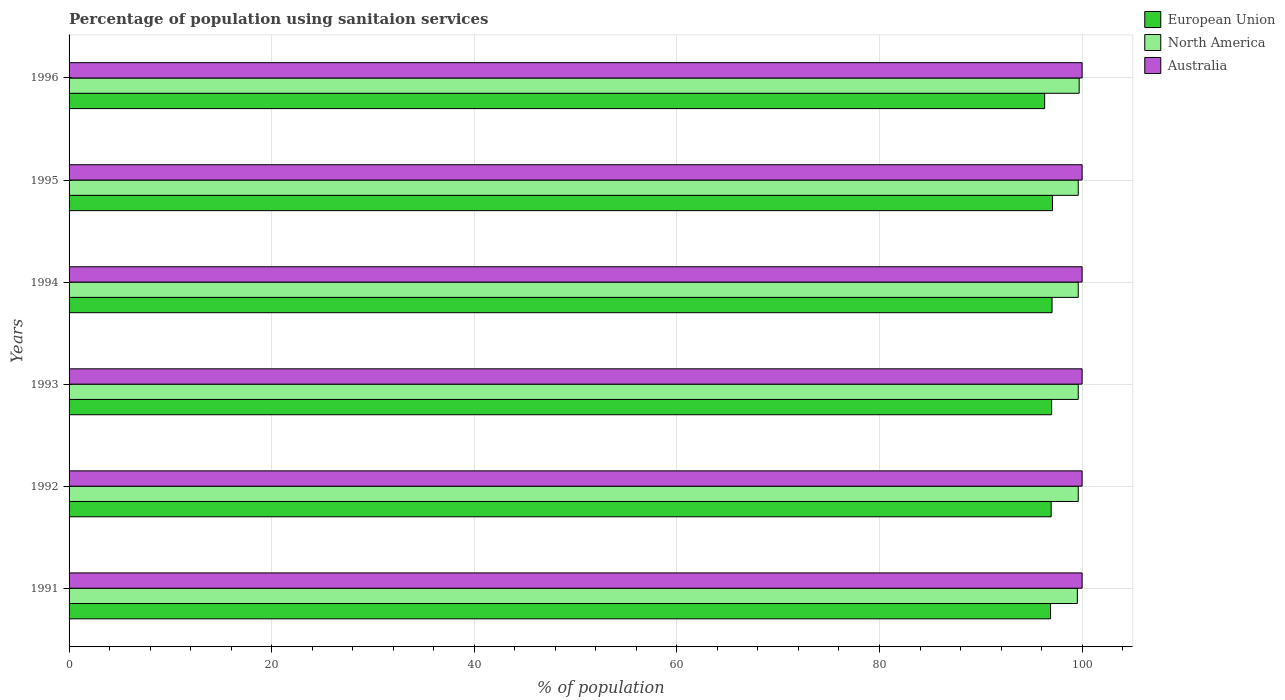How many different coloured bars are there?
Keep it short and to the point. 3. Are the number of bars per tick equal to the number of legend labels?
Give a very brief answer. Yes. How many bars are there on the 4th tick from the bottom?
Ensure brevity in your answer.  3. In how many cases, is the number of bars for a given year not equal to the number of legend labels?
Ensure brevity in your answer.  0. What is the percentage of population using sanitaion services in Australia in 1996?
Offer a terse response. 100. Across all years, what is the maximum percentage of population using sanitaion services in North America?
Provide a short and direct response. 99.71. Across all years, what is the minimum percentage of population using sanitaion services in North America?
Your answer should be compact. 99.53. What is the total percentage of population using sanitaion services in Australia in the graph?
Keep it short and to the point. 600. What is the difference between the percentage of population using sanitaion services in European Union in 1991 and that in 1993?
Ensure brevity in your answer.  -0.11. What is the difference between the percentage of population using sanitaion services in Australia in 1994 and the percentage of population using sanitaion services in European Union in 1996?
Give a very brief answer. 3.7. In the year 1995, what is the difference between the percentage of population using sanitaion services in European Union and percentage of population using sanitaion services in Australia?
Keep it short and to the point. -2.92. In how many years, is the percentage of population using sanitaion services in North America greater than 32 %?
Ensure brevity in your answer.  6. What is the ratio of the percentage of population using sanitaion services in Australia in 1993 to that in 1996?
Ensure brevity in your answer.  1. Is the percentage of population using sanitaion services in Australia in 1993 less than that in 1994?
Your answer should be very brief. No. Is the difference between the percentage of population using sanitaion services in European Union in 1991 and 1995 greater than the difference between the percentage of population using sanitaion services in Australia in 1991 and 1995?
Make the answer very short. No. What is the difference between the highest and the lowest percentage of population using sanitaion services in European Union?
Make the answer very short. 0.77. Is the sum of the percentage of population using sanitaion services in European Union in 1991 and 1993 greater than the maximum percentage of population using sanitaion services in North America across all years?
Keep it short and to the point. Yes. How many bars are there?
Keep it short and to the point. 18. How many years are there in the graph?
Ensure brevity in your answer.  6. Are the values on the major ticks of X-axis written in scientific E-notation?
Provide a short and direct response. No. Does the graph contain any zero values?
Keep it short and to the point. No. Does the graph contain grids?
Provide a succinct answer. Yes. Where does the legend appear in the graph?
Ensure brevity in your answer.  Top right. What is the title of the graph?
Keep it short and to the point. Percentage of population using sanitaion services. What is the label or title of the X-axis?
Provide a short and direct response. % of population. What is the label or title of the Y-axis?
Provide a succinct answer. Years. What is the % of population of European Union in 1991?
Offer a very short reply. 96.89. What is the % of population of North America in 1991?
Your answer should be very brief. 99.53. What is the % of population of Australia in 1991?
Your response must be concise. 100. What is the % of population in European Union in 1992?
Provide a succinct answer. 96.95. What is the % of population of North America in 1992?
Make the answer very short. 99.62. What is the % of population of Australia in 1992?
Provide a succinct answer. 100. What is the % of population in European Union in 1993?
Your response must be concise. 96.99. What is the % of population in North America in 1993?
Provide a succinct answer. 99.62. What is the % of population of European Union in 1994?
Keep it short and to the point. 97.03. What is the % of population in North America in 1994?
Keep it short and to the point. 99.62. What is the % of population in European Union in 1995?
Give a very brief answer. 97.08. What is the % of population of North America in 1995?
Give a very brief answer. 99.62. What is the % of population in Australia in 1995?
Provide a succinct answer. 100. What is the % of population in European Union in 1996?
Ensure brevity in your answer.  96.3. What is the % of population in North America in 1996?
Ensure brevity in your answer.  99.71. What is the % of population in Australia in 1996?
Provide a short and direct response. 100. Across all years, what is the maximum % of population of European Union?
Provide a succinct answer. 97.08. Across all years, what is the maximum % of population of North America?
Ensure brevity in your answer.  99.71. Across all years, what is the maximum % of population of Australia?
Provide a short and direct response. 100. Across all years, what is the minimum % of population in European Union?
Provide a succinct answer. 96.3. Across all years, what is the minimum % of population of North America?
Make the answer very short. 99.53. What is the total % of population in European Union in the graph?
Make the answer very short. 581.24. What is the total % of population in North America in the graph?
Provide a short and direct response. 597.72. What is the total % of population in Australia in the graph?
Keep it short and to the point. 600. What is the difference between the % of population in European Union in 1991 and that in 1992?
Provide a short and direct response. -0.06. What is the difference between the % of population of North America in 1991 and that in 1992?
Your response must be concise. -0.09. What is the difference between the % of population of Australia in 1991 and that in 1992?
Your response must be concise. 0. What is the difference between the % of population in European Union in 1991 and that in 1993?
Offer a terse response. -0.11. What is the difference between the % of population of North America in 1991 and that in 1993?
Provide a short and direct response. -0.09. What is the difference between the % of population of Australia in 1991 and that in 1993?
Provide a succinct answer. 0. What is the difference between the % of population in European Union in 1991 and that in 1994?
Provide a short and direct response. -0.15. What is the difference between the % of population in North America in 1991 and that in 1994?
Your answer should be compact. -0.09. What is the difference between the % of population of Australia in 1991 and that in 1994?
Your answer should be very brief. 0. What is the difference between the % of population in European Union in 1991 and that in 1995?
Offer a very short reply. -0.19. What is the difference between the % of population of North America in 1991 and that in 1995?
Offer a very short reply. -0.09. What is the difference between the % of population in European Union in 1991 and that in 1996?
Your response must be concise. 0.58. What is the difference between the % of population in North America in 1991 and that in 1996?
Offer a very short reply. -0.18. What is the difference between the % of population of European Union in 1992 and that in 1993?
Make the answer very short. -0.05. What is the difference between the % of population of North America in 1992 and that in 1993?
Give a very brief answer. 0. What is the difference between the % of population of European Union in 1992 and that in 1994?
Provide a succinct answer. -0.09. What is the difference between the % of population in Australia in 1992 and that in 1994?
Ensure brevity in your answer.  0. What is the difference between the % of population in European Union in 1992 and that in 1995?
Your answer should be very brief. -0.13. What is the difference between the % of population of North America in 1992 and that in 1995?
Your response must be concise. 0. What is the difference between the % of population of European Union in 1992 and that in 1996?
Ensure brevity in your answer.  0.64. What is the difference between the % of population in North America in 1992 and that in 1996?
Your answer should be very brief. -0.09. What is the difference between the % of population in Australia in 1992 and that in 1996?
Provide a succinct answer. 0. What is the difference between the % of population in European Union in 1993 and that in 1994?
Offer a terse response. -0.04. What is the difference between the % of population in Australia in 1993 and that in 1994?
Offer a terse response. 0. What is the difference between the % of population in European Union in 1993 and that in 1995?
Provide a succinct answer. -0.08. What is the difference between the % of population of North America in 1993 and that in 1995?
Offer a terse response. 0. What is the difference between the % of population in Australia in 1993 and that in 1995?
Offer a very short reply. 0. What is the difference between the % of population of European Union in 1993 and that in 1996?
Your answer should be very brief. 0.69. What is the difference between the % of population of North America in 1993 and that in 1996?
Give a very brief answer. -0.09. What is the difference between the % of population in European Union in 1994 and that in 1995?
Provide a succinct answer. -0.04. What is the difference between the % of population in North America in 1994 and that in 1995?
Keep it short and to the point. 0. What is the difference between the % of population of Australia in 1994 and that in 1995?
Provide a succinct answer. 0. What is the difference between the % of population in European Union in 1994 and that in 1996?
Make the answer very short. 0.73. What is the difference between the % of population of North America in 1994 and that in 1996?
Offer a very short reply. -0.09. What is the difference between the % of population in European Union in 1995 and that in 1996?
Your response must be concise. 0.77. What is the difference between the % of population of North America in 1995 and that in 1996?
Offer a terse response. -0.09. What is the difference between the % of population of European Union in 1991 and the % of population of North America in 1992?
Provide a short and direct response. -2.73. What is the difference between the % of population of European Union in 1991 and the % of population of Australia in 1992?
Make the answer very short. -3.11. What is the difference between the % of population in North America in 1991 and the % of population in Australia in 1992?
Keep it short and to the point. -0.47. What is the difference between the % of population in European Union in 1991 and the % of population in North America in 1993?
Provide a short and direct response. -2.73. What is the difference between the % of population of European Union in 1991 and the % of population of Australia in 1993?
Give a very brief answer. -3.11. What is the difference between the % of population of North America in 1991 and the % of population of Australia in 1993?
Your answer should be compact. -0.47. What is the difference between the % of population of European Union in 1991 and the % of population of North America in 1994?
Provide a short and direct response. -2.73. What is the difference between the % of population of European Union in 1991 and the % of population of Australia in 1994?
Your answer should be compact. -3.11. What is the difference between the % of population in North America in 1991 and the % of population in Australia in 1994?
Offer a terse response. -0.47. What is the difference between the % of population of European Union in 1991 and the % of population of North America in 1995?
Offer a terse response. -2.73. What is the difference between the % of population in European Union in 1991 and the % of population in Australia in 1995?
Your answer should be very brief. -3.11. What is the difference between the % of population in North America in 1991 and the % of population in Australia in 1995?
Offer a very short reply. -0.47. What is the difference between the % of population of European Union in 1991 and the % of population of North America in 1996?
Make the answer very short. -2.82. What is the difference between the % of population in European Union in 1991 and the % of population in Australia in 1996?
Keep it short and to the point. -3.11. What is the difference between the % of population in North America in 1991 and the % of population in Australia in 1996?
Ensure brevity in your answer.  -0.47. What is the difference between the % of population in European Union in 1992 and the % of population in North America in 1993?
Provide a succinct answer. -2.67. What is the difference between the % of population of European Union in 1992 and the % of population of Australia in 1993?
Your response must be concise. -3.05. What is the difference between the % of population of North America in 1992 and the % of population of Australia in 1993?
Your answer should be compact. -0.38. What is the difference between the % of population of European Union in 1992 and the % of population of North America in 1994?
Give a very brief answer. -2.67. What is the difference between the % of population of European Union in 1992 and the % of population of Australia in 1994?
Give a very brief answer. -3.05. What is the difference between the % of population of North America in 1992 and the % of population of Australia in 1994?
Give a very brief answer. -0.38. What is the difference between the % of population in European Union in 1992 and the % of population in North America in 1995?
Ensure brevity in your answer.  -2.67. What is the difference between the % of population of European Union in 1992 and the % of population of Australia in 1995?
Provide a short and direct response. -3.05. What is the difference between the % of population in North America in 1992 and the % of population in Australia in 1995?
Your answer should be compact. -0.38. What is the difference between the % of population of European Union in 1992 and the % of population of North America in 1996?
Offer a very short reply. -2.76. What is the difference between the % of population of European Union in 1992 and the % of population of Australia in 1996?
Make the answer very short. -3.05. What is the difference between the % of population in North America in 1992 and the % of population in Australia in 1996?
Your response must be concise. -0.38. What is the difference between the % of population in European Union in 1993 and the % of population in North America in 1994?
Your answer should be very brief. -2.63. What is the difference between the % of population of European Union in 1993 and the % of population of Australia in 1994?
Your answer should be compact. -3.01. What is the difference between the % of population in North America in 1993 and the % of population in Australia in 1994?
Provide a succinct answer. -0.38. What is the difference between the % of population of European Union in 1993 and the % of population of North America in 1995?
Your response must be concise. -2.63. What is the difference between the % of population in European Union in 1993 and the % of population in Australia in 1995?
Ensure brevity in your answer.  -3.01. What is the difference between the % of population in North America in 1993 and the % of population in Australia in 1995?
Your answer should be very brief. -0.38. What is the difference between the % of population of European Union in 1993 and the % of population of North America in 1996?
Provide a short and direct response. -2.72. What is the difference between the % of population of European Union in 1993 and the % of population of Australia in 1996?
Keep it short and to the point. -3.01. What is the difference between the % of population of North America in 1993 and the % of population of Australia in 1996?
Offer a very short reply. -0.38. What is the difference between the % of population of European Union in 1994 and the % of population of North America in 1995?
Provide a short and direct response. -2.59. What is the difference between the % of population of European Union in 1994 and the % of population of Australia in 1995?
Provide a short and direct response. -2.97. What is the difference between the % of population of North America in 1994 and the % of population of Australia in 1995?
Provide a succinct answer. -0.38. What is the difference between the % of population of European Union in 1994 and the % of population of North America in 1996?
Give a very brief answer. -2.68. What is the difference between the % of population of European Union in 1994 and the % of population of Australia in 1996?
Give a very brief answer. -2.97. What is the difference between the % of population of North America in 1994 and the % of population of Australia in 1996?
Ensure brevity in your answer.  -0.38. What is the difference between the % of population in European Union in 1995 and the % of population in North America in 1996?
Give a very brief answer. -2.63. What is the difference between the % of population in European Union in 1995 and the % of population in Australia in 1996?
Provide a succinct answer. -2.92. What is the difference between the % of population in North America in 1995 and the % of population in Australia in 1996?
Your response must be concise. -0.38. What is the average % of population in European Union per year?
Your answer should be very brief. 96.87. What is the average % of population in North America per year?
Your response must be concise. 99.62. What is the average % of population of Australia per year?
Give a very brief answer. 100. In the year 1991, what is the difference between the % of population in European Union and % of population in North America?
Offer a terse response. -2.64. In the year 1991, what is the difference between the % of population of European Union and % of population of Australia?
Ensure brevity in your answer.  -3.11. In the year 1991, what is the difference between the % of population in North America and % of population in Australia?
Your response must be concise. -0.47. In the year 1992, what is the difference between the % of population of European Union and % of population of North America?
Provide a succinct answer. -2.67. In the year 1992, what is the difference between the % of population in European Union and % of population in Australia?
Provide a short and direct response. -3.05. In the year 1992, what is the difference between the % of population of North America and % of population of Australia?
Your response must be concise. -0.38. In the year 1993, what is the difference between the % of population of European Union and % of population of North America?
Provide a short and direct response. -2.63. In the year 1993, what is the difference between the % of population of European Union and % of population of Australia?
Your response must be concise. -3.01. In the year 1993, what is the difference between the % of population in North America and % of population in Australia?
Keep it short and to the point. -0.38. In the year 1994, what is the difference between the % of population in European Union and % of population in North America?
Provide a short and direct response. -2.59. In the year 1994, what is the difference between the % of population in European Union and % of population in Australia?
Provide a short and direct response. -2.97. In the year 1994, what is the difference between the % of population of North America and % of population of Australia?
Provide a short and direct response. -0.38. In the year 1995, what is the difference between the % of population of European Union and % of population of North America?
Make the answer very short. -2.54. In the year 1995, what is the difference between the % of population in European Union and % of population in Australia?
Offer a very short reply. -2.92. In the year 1995, what is the difference between the % of population in North America and % of population in Australia?
Your answer should be very brief. -0.38. In the year 1996, what is the difference between the % of population of European Union and % of population of North America?
Your answer should be very brief. -3.41. In the year 1996, what is the difference between the % of population in European Union and % of population in Australia?
Your answer should be compact. -3.7. In the year 1996, what is the difference between the % of population in North America and % of population in Australia?
Keep it short and to the point. -0.29. What is the ratio of the % of population in Australia in 1991 to that in 1992?
Offer a very short reply. 1. What is the ratio of the % of population of European Union in 1991 to that in 1993?
Give a very brief answer. 1. What is the ratio of the % of population of Australia in 1991 to that in 1993?
Your answer should be compact. 1. What is the ratio of the % of population of European Union in 1991 to that in 1994?
Offer a terse response. 1. What is the ratio of the % of population in North America in 1991 to that in 1994?
Make the answer very short. 1. What is the ratio of the % of population in Australia in 1991 to that in 1994?
Provide a short and direct response. 1. What is the ratio of the % of population of European Union in 1991 to that in 1995?
Ensure brevity in your answer.  1. What is the ratio of the % of population in North America in 1991 to that in 1995?
Your answer should be compact. 1. What is the ratio of the % of population in North America in 1992 to that in 1994?
Ensure brevity in your answer.  1. What is the ratio of the % of population in European Union in 1992 to that in 1996?
Offer a very short reply. 1.01. What is the ratio of the % of population of North America in 1992 to that in 1996?
Your response must be concise. 1. What is the ratio of the % of population in Australia in 1992 to that in 1996?
Your response must be concise. 1. What is the ratio of the % of population in European Union in 1993 to that in 1994?
Your response must be concise. 1. What is the ratio of the % of population in North America in 1993 to that in 1994?
Offer a terse response. 1. What is the ratio of the % of population of North America in 1993 to that in 1995?
Your response must be concise. 1. What is the ratio of the % of population of European Union in 1993 to that in 1996?
Give a very brief answer. 1.01. What is the ratio of the % of population in North America in 1993 to that in 1996?
Ensure brevity in your answer.  1. What is the ratio of the % of population in Australia in 1993 to that in 1996?
Offer a terse response. 1. What is the ratio of the % of population of European Union in 1994 to that in 1995?
Offer a terse response. 1. What is the ratio of the % of population in North America in 1994 to that in 1995?
Offer a terse response. 1. What is the ratio of the % of population in European Union in 1994 to that in 1996?
Your answer should be very brief. 1.01. What is the ratio of the % of population of Australia in 1994 to that in 1996?
Make the answer very short. 1. What is the ratio of the % of population of European Union in 1995 to that in 1996?
Provide a succinct answer. 1.01. What is the ratio of the % of population of North America in 1995 to that in 1996?
Ensure brevity in your answer.  1. What is the difference between the highest and the second highest % of population of European Union?
Offer a terse response. 0.04. What is the difference between the highest and the second highest % of population in North America?
Your answer should be very brief. 0.09. What is the difference between the highest and the lowest % of population in European Union?
Your response must be concise. 0.77. What is the difference between the highest and the lowest % of population in North America?
Your response must be concise. 0.18. 